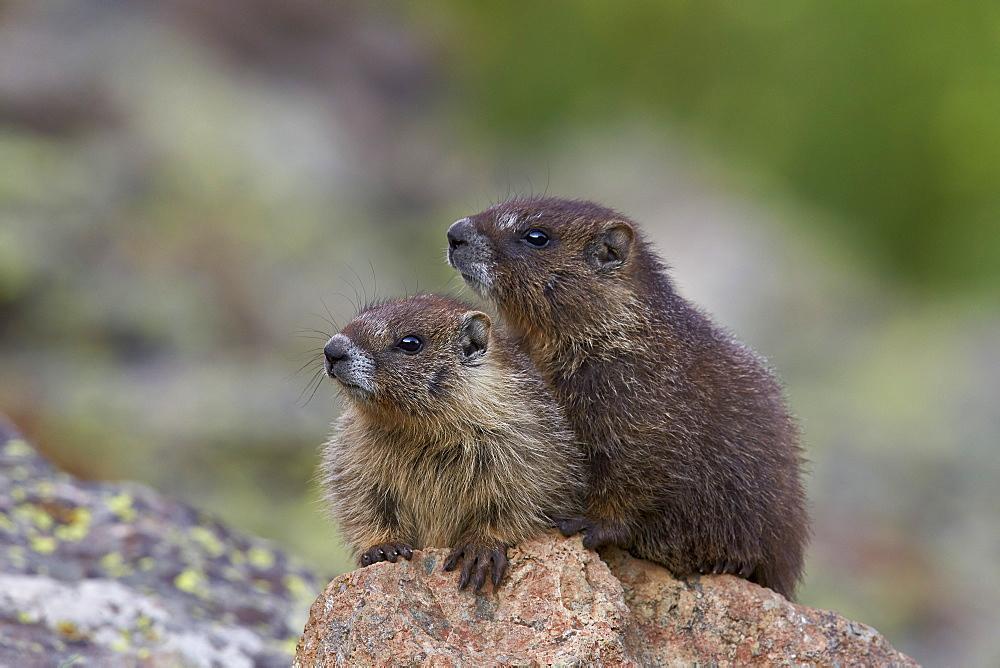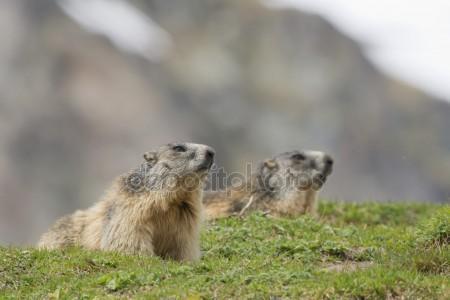The first image is the image on the left, the second image is the image on the right. For the images shown, is this caption "There are two rodents in the right image that are facing towards the right." true? Answer yes or no. Yes. 